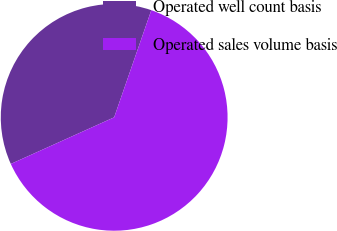Convert chart to OTSL. <chart><loc_0><loc_0><loc_500><loc_500><pie_chart><fcel>Operated well count basis<fcel>Operated sales volume basis<nl><fcel>37.05%<fcel>62.95%<nl></chart> 